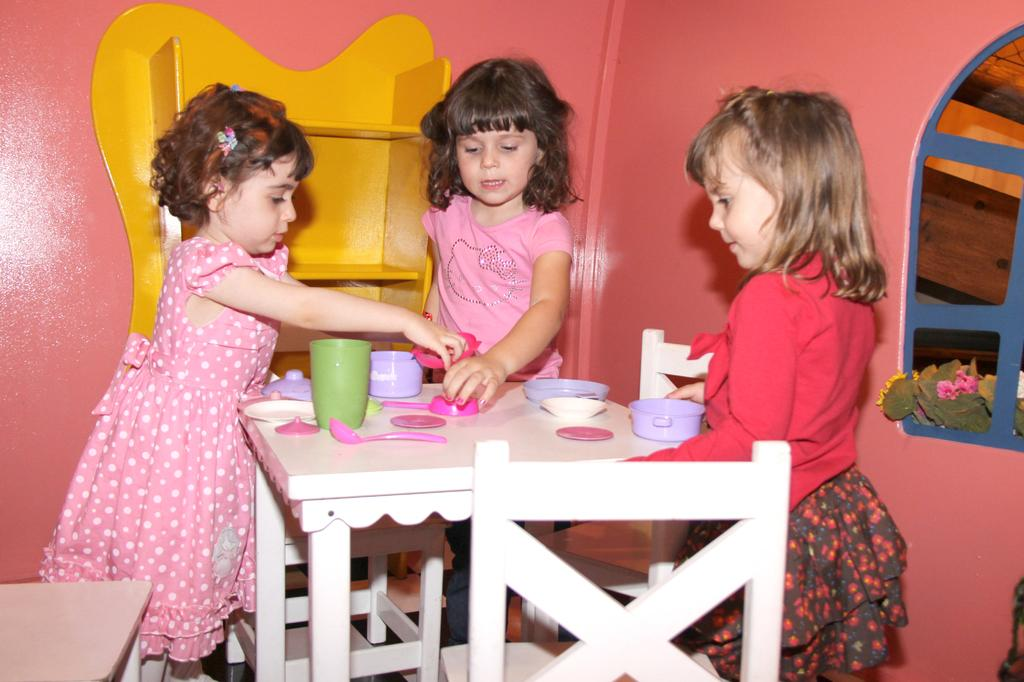What can be seen in the image regarding the people present? There are girls standing in the image. What is on the table in the image? There is a cup, a bowl, and other objects on the table. What color is the shelf in the image? The shelf in the image is yellow. What color is the table in the image? The table in the image is pink. What type of furniture is present in the image? There is a chair in the image. What is the color of the wall in the image? The wall in the image is pink in color. What type of operation is being performed on the playground in the image? There is no playground or operation present in the image. 